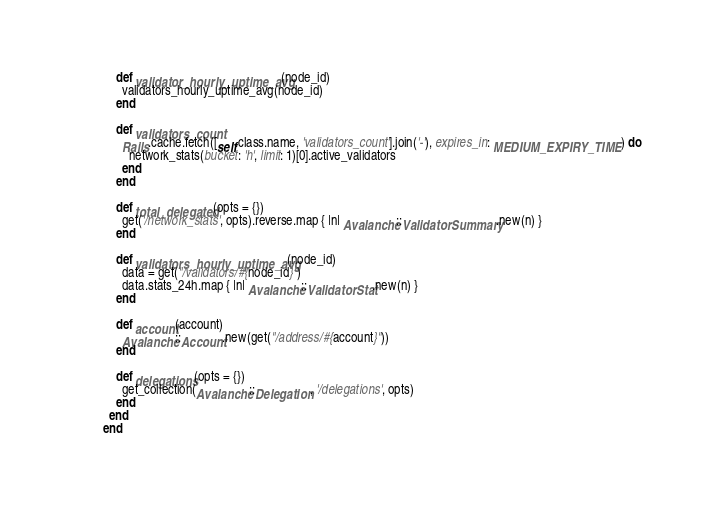<code> <loc_0><loc_0><loc_500><loc_500><_Ruby_>
    def validator_hourly_uptime_avg(node_id)
      validators_hourly_uptime_avg(node_id)
    end

    def validators_count
      Rails.cache.fetch([self.class.name, 'validators_count'].join('-'), expires_in: MEDIUM_EXPIRY_TIME) do
        network_stats(bucket: 'h', limit: 1)[0].active_validators
      end
    end

    def total_delegated(opts = {})
      get('/network_stats', opts).reverse.map { |n| Avalanche::ValidatorSummary.new(n) }
    end

    def validators_hourly_uptime_avg(node_id)
      data = get("/validators/#{node_id}")
      data.stats_24h.map { |n| Avalanche::ValidatorStat.new(n) }
    end

    def account(account)
      Avalanche::Account.new(get("/address/#{account}"))
    end

    def delegations(opts = {})
      get_collection(Avalanche::Delegation, '/delegations', opts)
    end
  end
end
</code> 